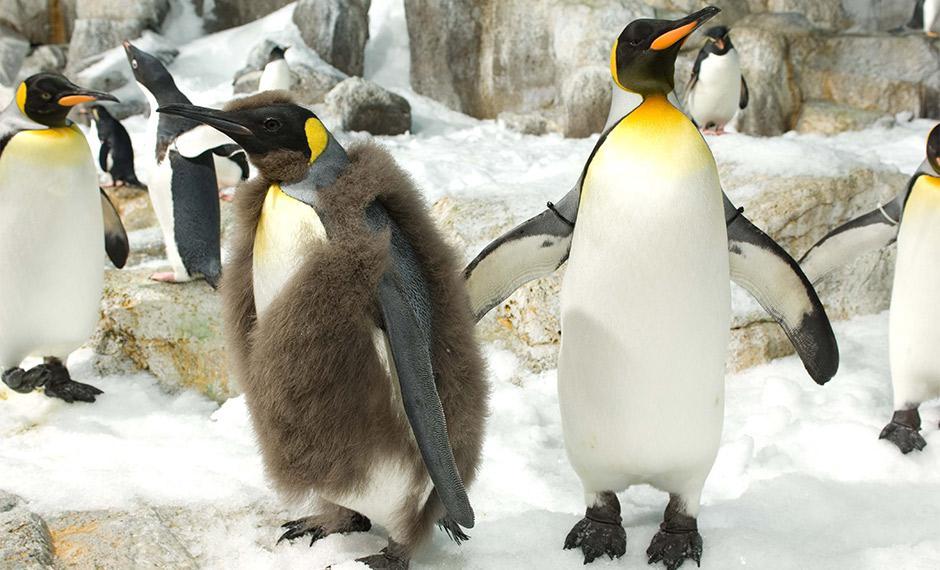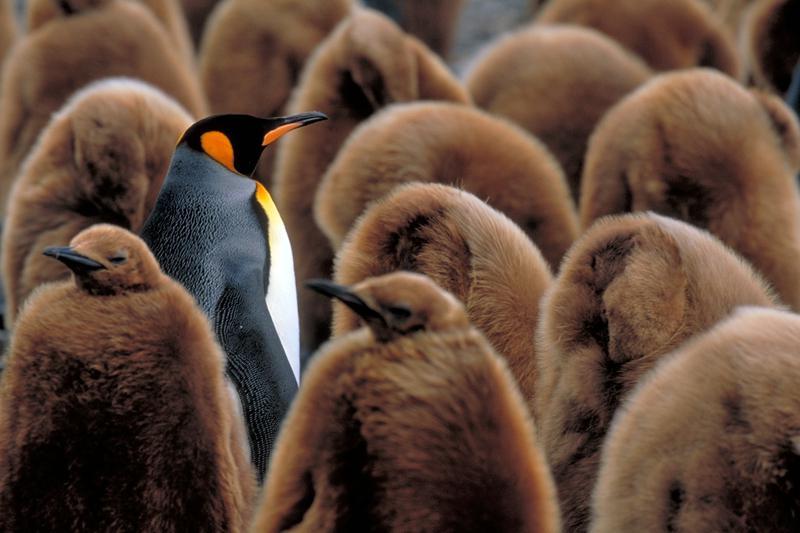The first image is the image on the left, the second image is the image on the right. For the images shown, is this caption "There is less than four penguins in at least one of the images." true? Answer yes or no. No. The first image is the image on the left, the second image is the image on the right. Evaluate the accuracy of this statement regarding the images: "An image shows a flock of mostly brown-feathered penguins.". Is it true? Answer yes or no. Yes. 